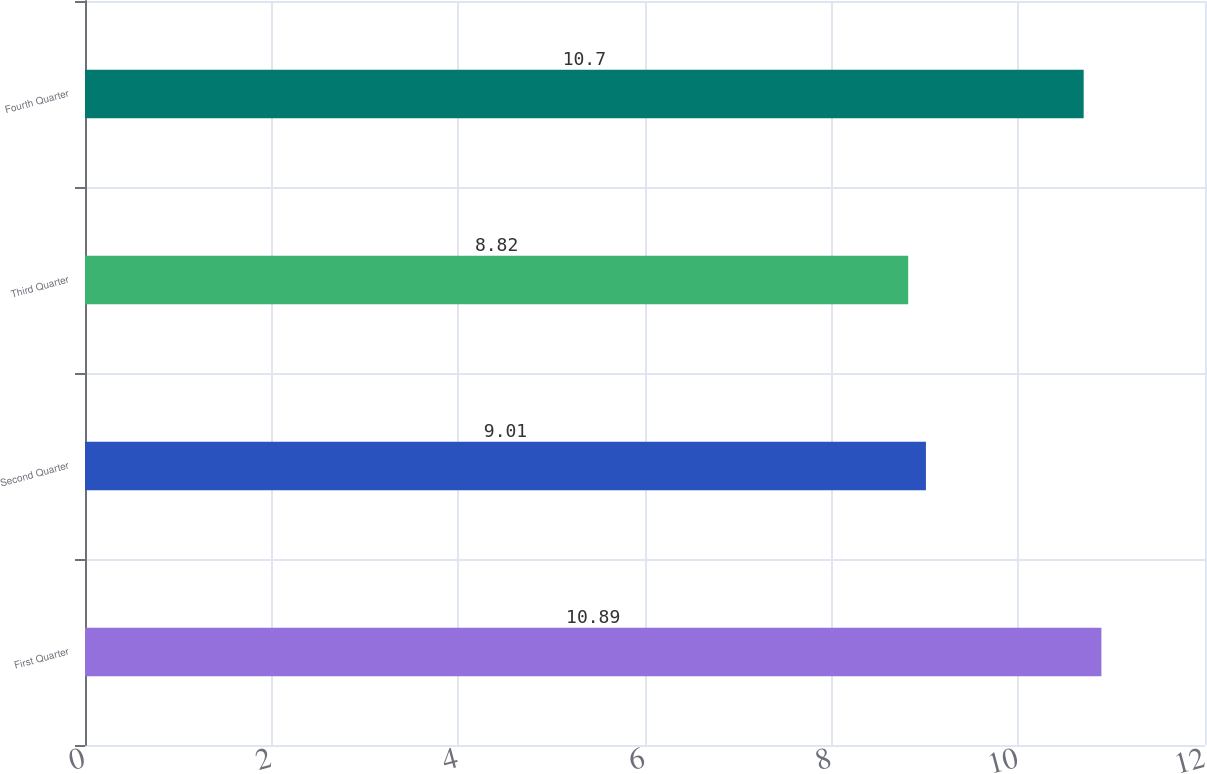Convert chart. <chart><loc_0><loc_0><loc_500><loc_500><bar_chart><fcel>First Quarter<fcel>Second Quarter<fcel>Third Quarter<fcel>Fourth Quarter<nl><fcel>10.89<fcel>9.01<fcel>8.82<fcel>10.7<nl></chart> 